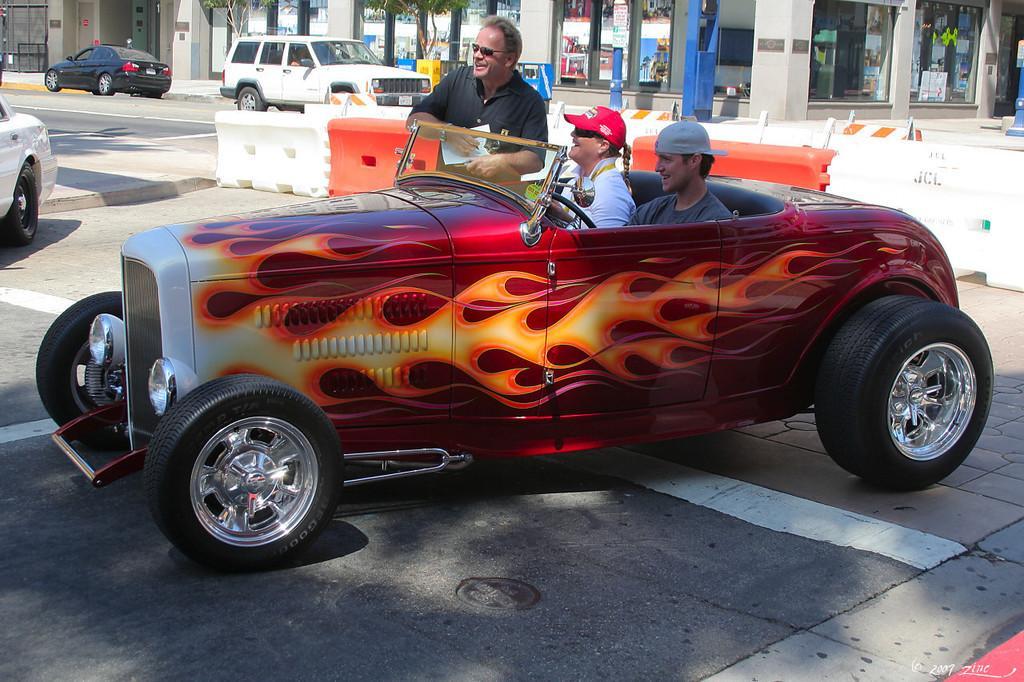Please provide a concise description of this image. In this image I can see two persons sitting in the car and one person is standing. At the back side we can see cars and a building. 